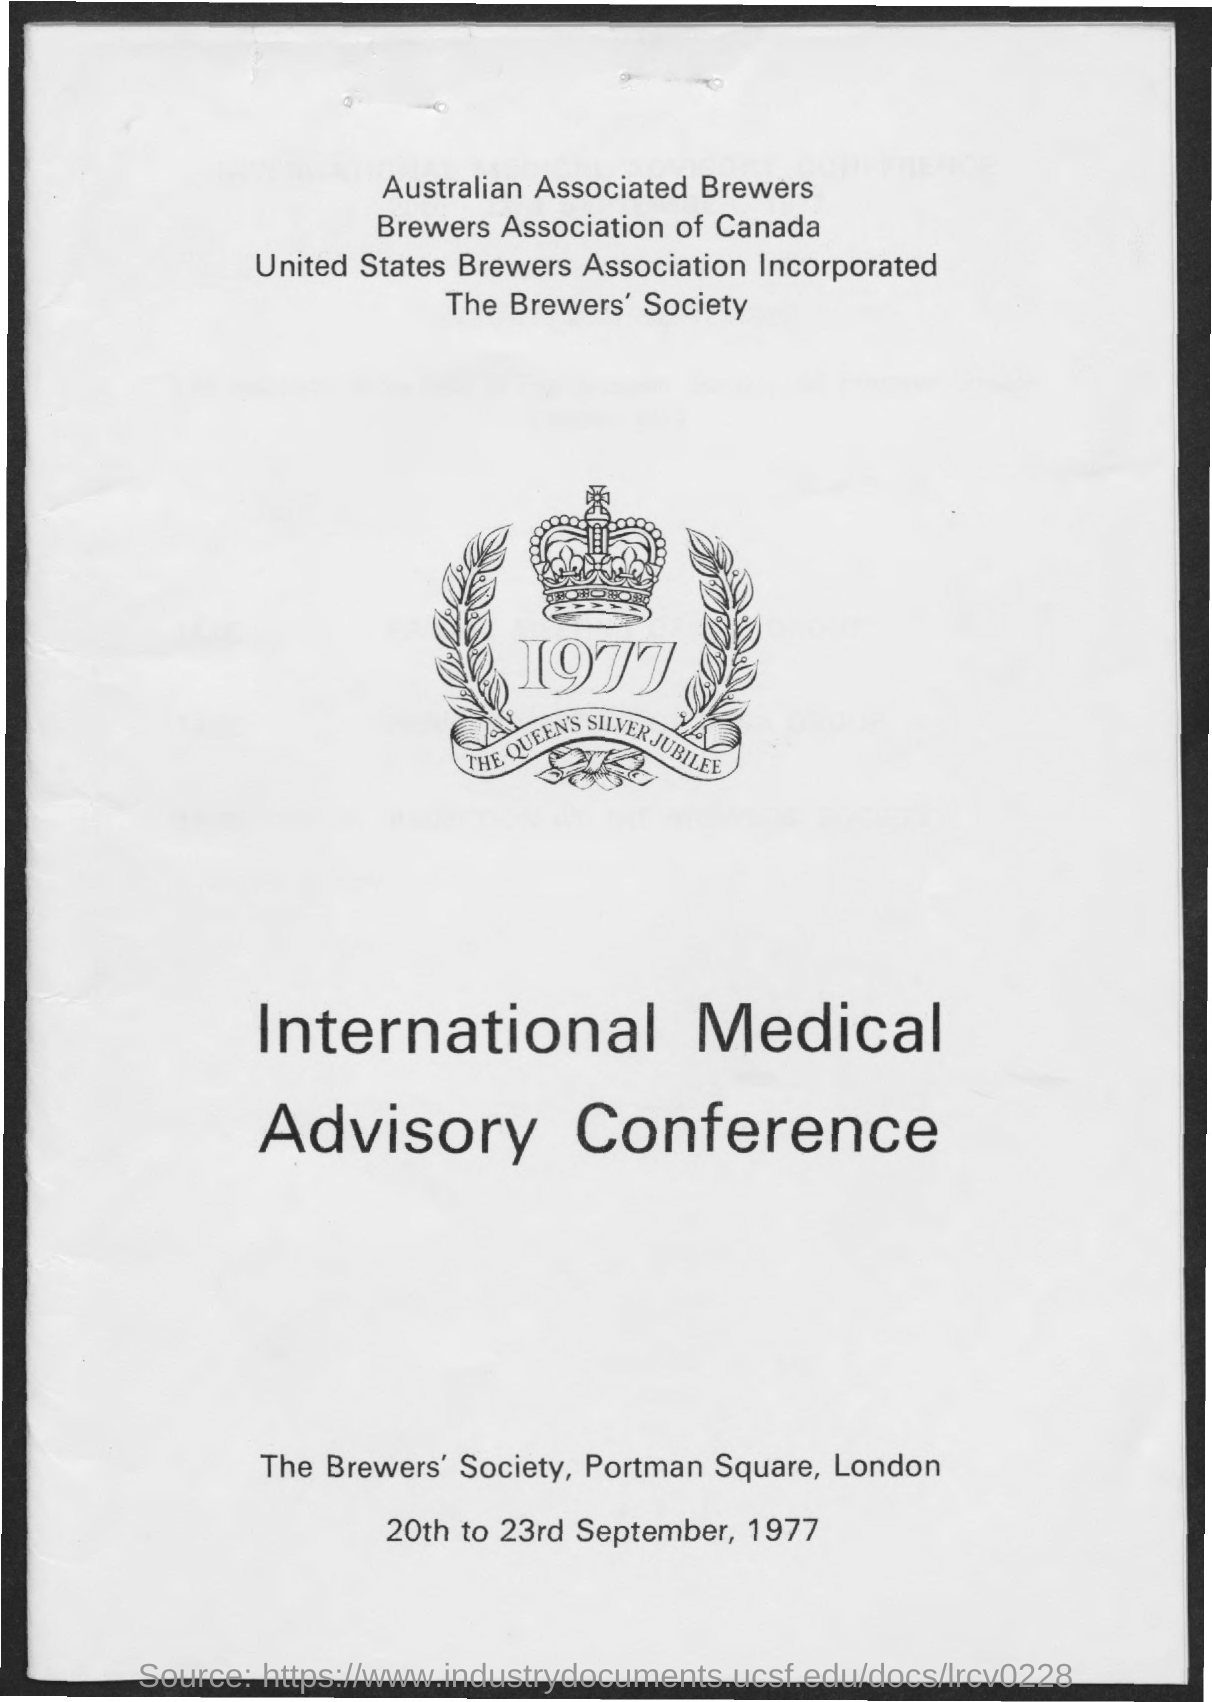Give some essential details in this illustration. The International Medical Advisory Conference is a conference that has been mentioned. The date mentioned in the given page is from 20th to 23rd September, 1977. 